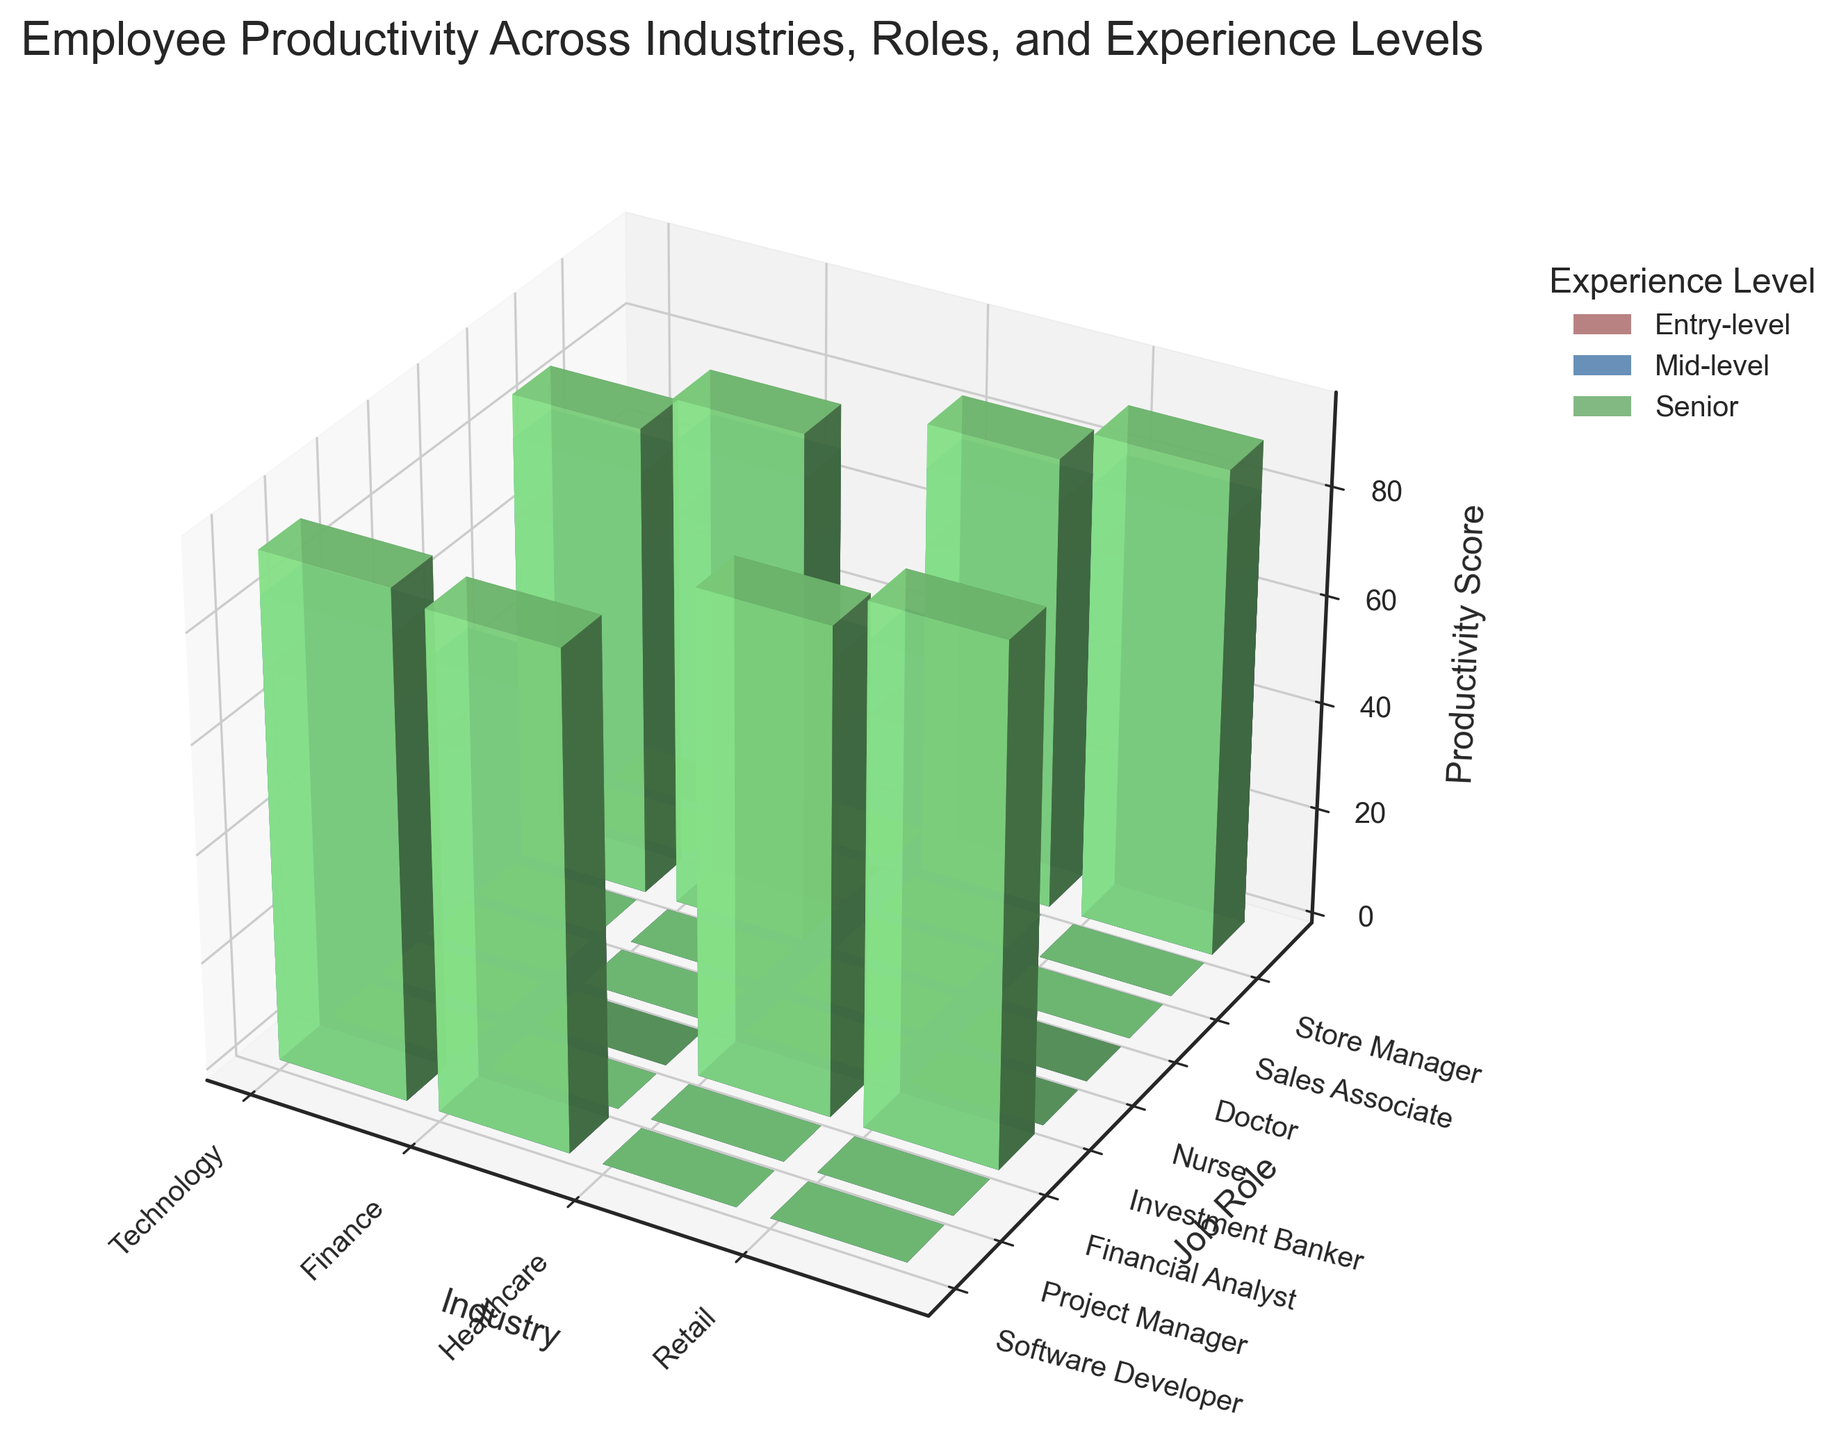What's the title of the plot? The title of the plot is typically displayed at the top of the figure. By looking at the figure, we can see the text.
Answer: Employee Productivity Across Industries, Roles, and Experience Levels How many different industries are compared in the plot? The number of industries can be determined by counting the unique labels on the x-axis, which correspond to the different industries in the plot.
Answer: 4 What is the color used to represent Senior level experience? The color representing Senior level experience can be identified by looking at the legend of the plot.
Answer: Green Which job role in the Healthcare industry has the highest productivity score for the Senior level experience? To find the highest productivity score for Senior level experience in the Healthcare industry, we look for the highest bar within the Healthcare industry at the position corresponding to Senior level experience.
Answer: Doctor What is the productivity score for a Mid-level Financial Analyst? The productivity score for a Mid-level Financial Analyst can be found by locating the corresponding bar in the Finance industry for the Mid-level experience level and checking its height.
Answer: 83 Which industry shows the largest difference in productivity scores between Entry-level and Senior-level Software Developers? To determine the industry with the largest difference, examine the height of the bars for Entry-level and Senior-level Software Developers in each industry, and compute the differences.
Answer: Technology What is the average productivity score for Entry-level employees across all industries? Calculate by summing the productivity scores of Entry-level employees across all industries, then divide by the number of Entry-level data points. The sum is 72 + 68 + 70 + 75 + 65 + 73 + 62 + 69 = 554. Dividing by 8 gives 554 / 8 = 69.25.
Answer: 69.25 Is the productivity score for Senior-level Investment Bankers higher than for Senior-level Store Managers? Compare the height of the bars representing Senior-level Investment Bankers and Senior-level Store Managers.
Answer: Yes Which role within the Retail industry has the lowest productivity score at the Entry-level experience? Within the Retail industry, compare the bars representing Entry-level experience for each job role.
Answer: Sales Associate What is the total sum of productivity scores for Mid-level employees in the Technology industry? Sum the productivity scores for all Mid-level employees within the Technology industry. The values are 85 + 82 = 167.
Answer: 167 